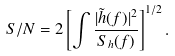Convert formula to latex. <formula><loc_0><loc_0><loc_500><loc_500>S / N = 2 \left [ \int \frac { | \tilde { h } ( f ) | ^ { 2 } } { S _ { h } ( f ) } \right ] ^ { 1 / 2 } .</formula> 